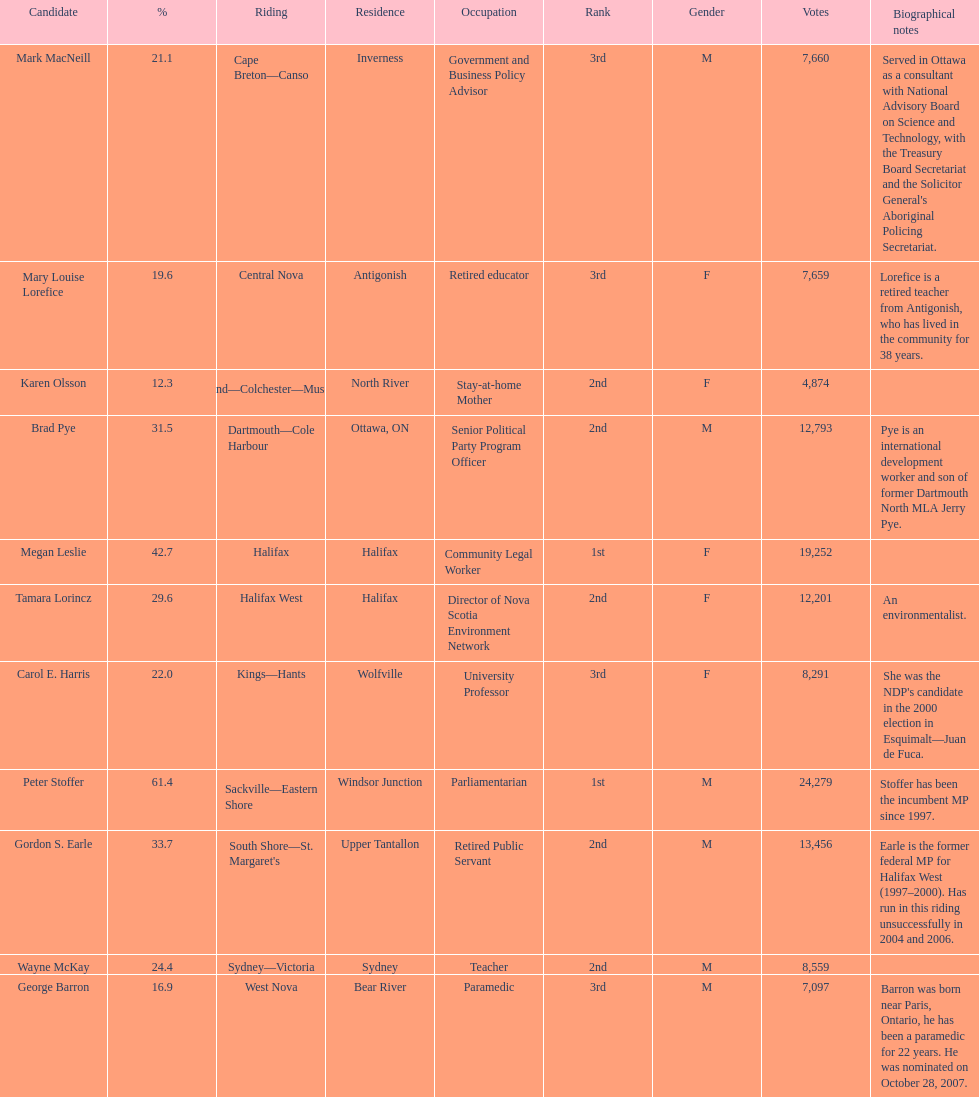Who were the new democratic party candidates, 2008? Mark MacNeill, Mary Louise Lorefice, Karen Olsson, Brad Pye, Megan Leslie, Tamara Lorincz, Carol E. Harris, Peter Stoffer, Gordon S. Earle, Wayne McKay, George Barron. Who had the 2nd highest number of votes? Megan Leslie, Peter Stoffer. Would you be able to parse every entry in this table? {'header': ['Candidate', '%', 'Riding', 'Residence', 'Occupation', 'Rank', 'Gender', 'Votes', 'Biographical notes'], 'rows': [['Mark MacNeill', '21.1', 'Cape Breton—Canso', 'Inverness', 'Government and Business Policy Advisor', '3rd', 'M', '7,660', "Served in Ottawa as a consultant with National Advisory Board on Science and Technology, with the Treasury Board Secretariat and the Solicitor General's Aboriginal Policing Secretariat."], ['Mary Louise Lorefice', '19.6', 'Central Nova', 'Antigonish', 'Retired educator', '3rd', 'F', '7,659', 'Lorefice is a retired teacher from Antigonish, who has lived in the community for 38 years.'], ['Karen Olsson', '12.3', 'Cumberland—Colchester—Musquodoboit Valley', 'North River', 'Stay-at-home Mother', '2nd', 'F', '4,874', ''], ['Brad Pye', '31.5', 'Dartmouth—Cole Harbour', 'Ottawa, ON', 'Senior Political Party Program Officer', '2nd', 'M', '12,793', 'Pye is an international development worker and son of former Dartmouth North MLA Jerry Pye.'], ['Megan Leslie', '42.7', 'Halifax', 'Halifax', 'Community Legal Worker', '1st', 'F', '19,252', ''], ['Tamara Lorincz', '29.6', 'Halifax West', 'Halifax', 'Director of Nova Scotia Environment Network', '2nd', 'F', '12,201', 'An environmentalist.'], ['Carol E. Harris', '22.0', 'Kings—Hants', 'Wolfville', 'University Professor', '3rd', 'F', '8,291', "She was the NDP's candidate in the 2000 election in Esquimalt—Juan de Fuca."], ['Peter Stoffer', '61.4', 'Sackville—Eastern Shore', 'Windsor Junction', 'Parliamentarian', '1st', 'M', '24,279', 'Stoffer has been the incumbent MP since 1997.'], ['Gordon S. Earle', '33.7', "South Shore—St. Margaret's", 'Upper Tantallon', 'Retired Public Servant', '2nd', 'M', '13,456', 'Earle is the former federal MP for Halifax West (1997–2000). Has run in this riding unsuccessfully in 2004 and 2006.'], ['Wayne McKay', '24.4', 'Sydney—Victoria', 'Sydney', 'Teacher', '2nd', 'M', '8,559', ''], ['George Barron', '16.9', 'West Nova', 'Bear River', 'Paramedic', '3rd', 'M', '7,097', 'Barron was born near Paris, Ontario, he has been a paramedic for 22 years. He was nominated on October 28, 2007.']]} How many votes did she receive? 19,252. 